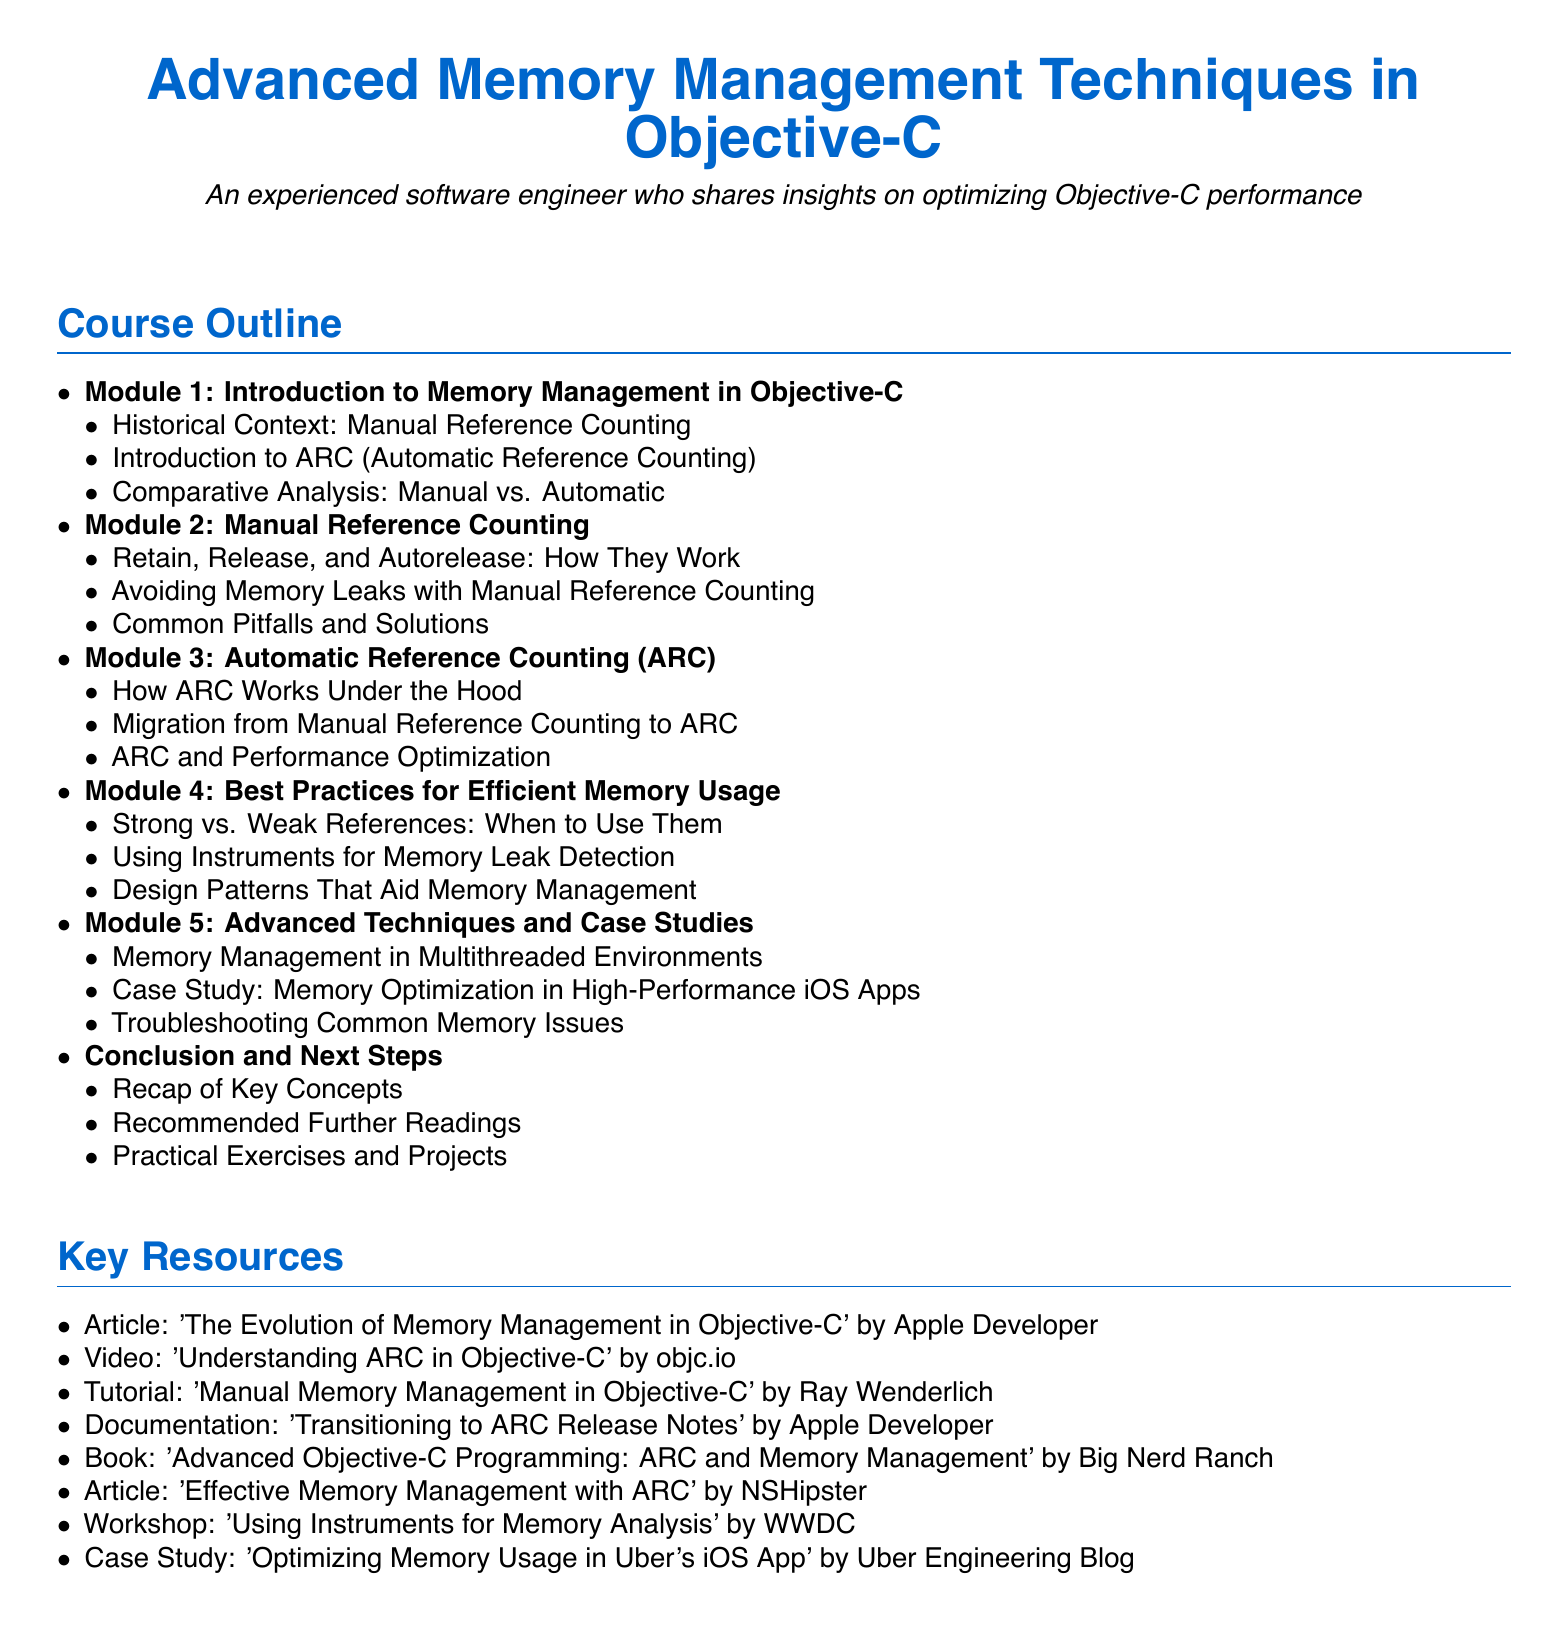What is the title of Module 1? The title of Module 1 is "Introduction to Memory Management in Objective-C," as stated in the document.
Answer: Introduction to Memory Management in Objective-C How many modules are there in the syllabus? The syllabus lists a total of 5 modules in the course outline, indicated by the itemized list.
Answer: 5 Who authored the article recommended as a key resource? The author of the article "The Evolution of Memory Management in Objective-C" is specified as Apple Developer in the key resources section.
Answer: Apple Developer What topic is covered in Module 3? Module 3 covers "Automatic Reference Counting (ARC)," as outlined in the course modules.
Answer: Automatic Reference Counting (ARC) What is a purpose of using Instruments in memory management? The syllabus mentions using Instruments for "Memory Leak Detection" which implies its role in identifying memory management issues.
Answer: Memory Leak Detection In which module is "Common Pitfalls and Solutions" discussed? The discussion on "Common Pitfalls and Solutions" can be found in Module 2, which focuses on Manual Reference Counting.
Answer: Module 2 What type of environments is the advanced technique in Module 5 related to? Module 5 discusses "Memory Management in Multithreaded Environments," indicating its focus on concurrent processing scenarios.
Answer: Multithreaded Environments Which book is listed under Key Resources? The book "Advanced Objective-C Programming: ARC and Memory Management" is specified as one of the key resources.
Answer: Advanced Objective-C Programming: ARC and Memory Management 